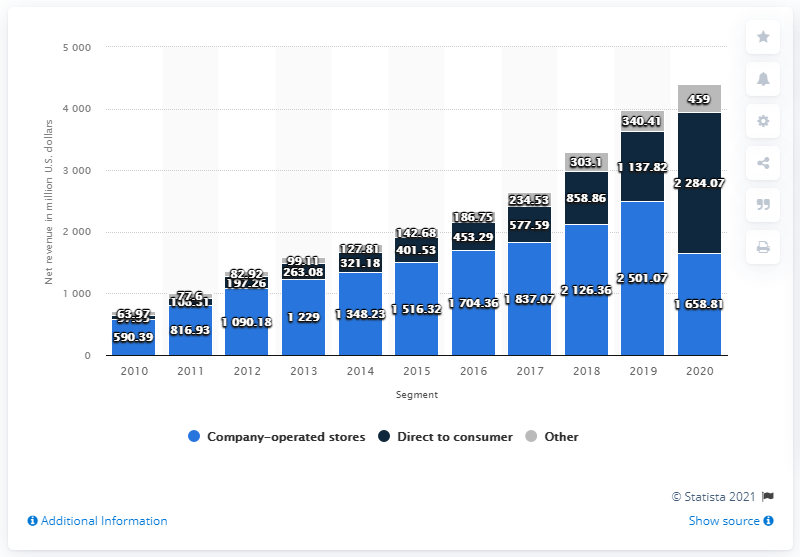Specify some key components in this picture. The net revenue from lululemon's direct to consumer channel in the fiscal year of 2020 was $2284.07. 